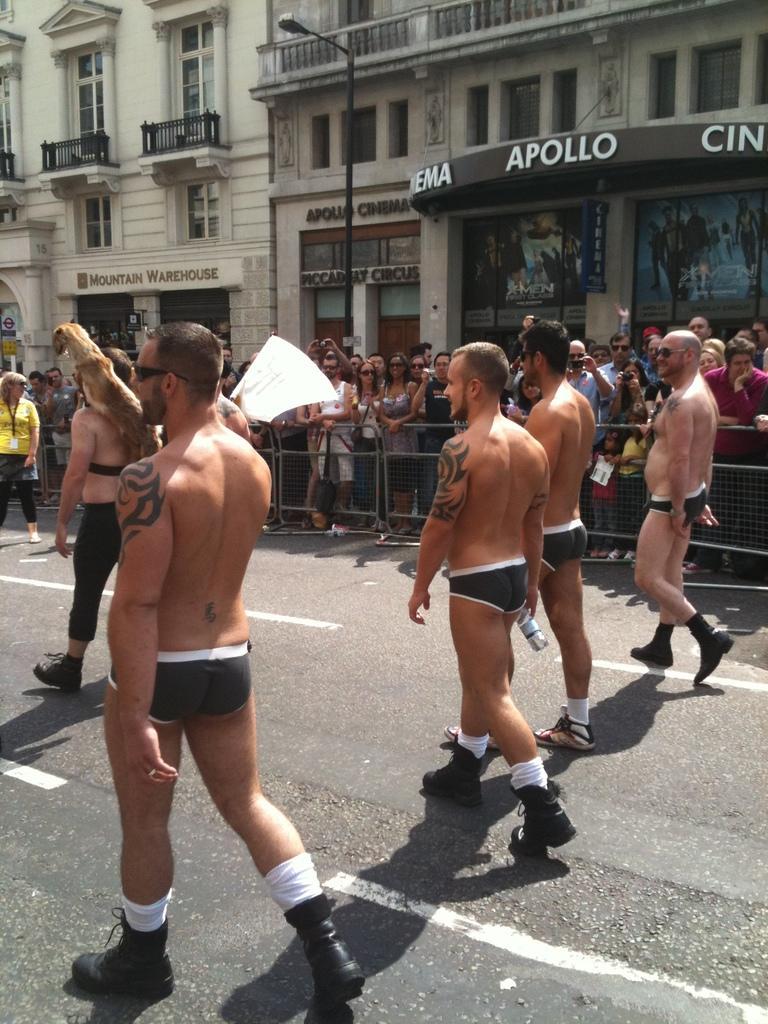In one or two sentences, can you explain what this image depicts? The picture is taken on street of a city. In the foreground of the picture there are people walking down the road. In the center of the picture there are people standing near barricades. In the background there are buildings, street light, windows and other objects. 